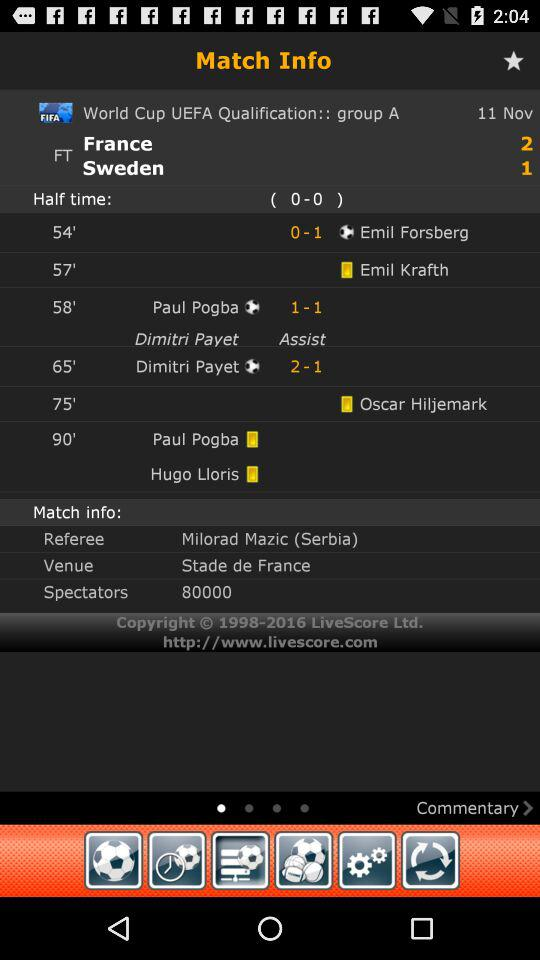How many goals were scored in the first half?
Answer the question using a single word or phrase. 0 